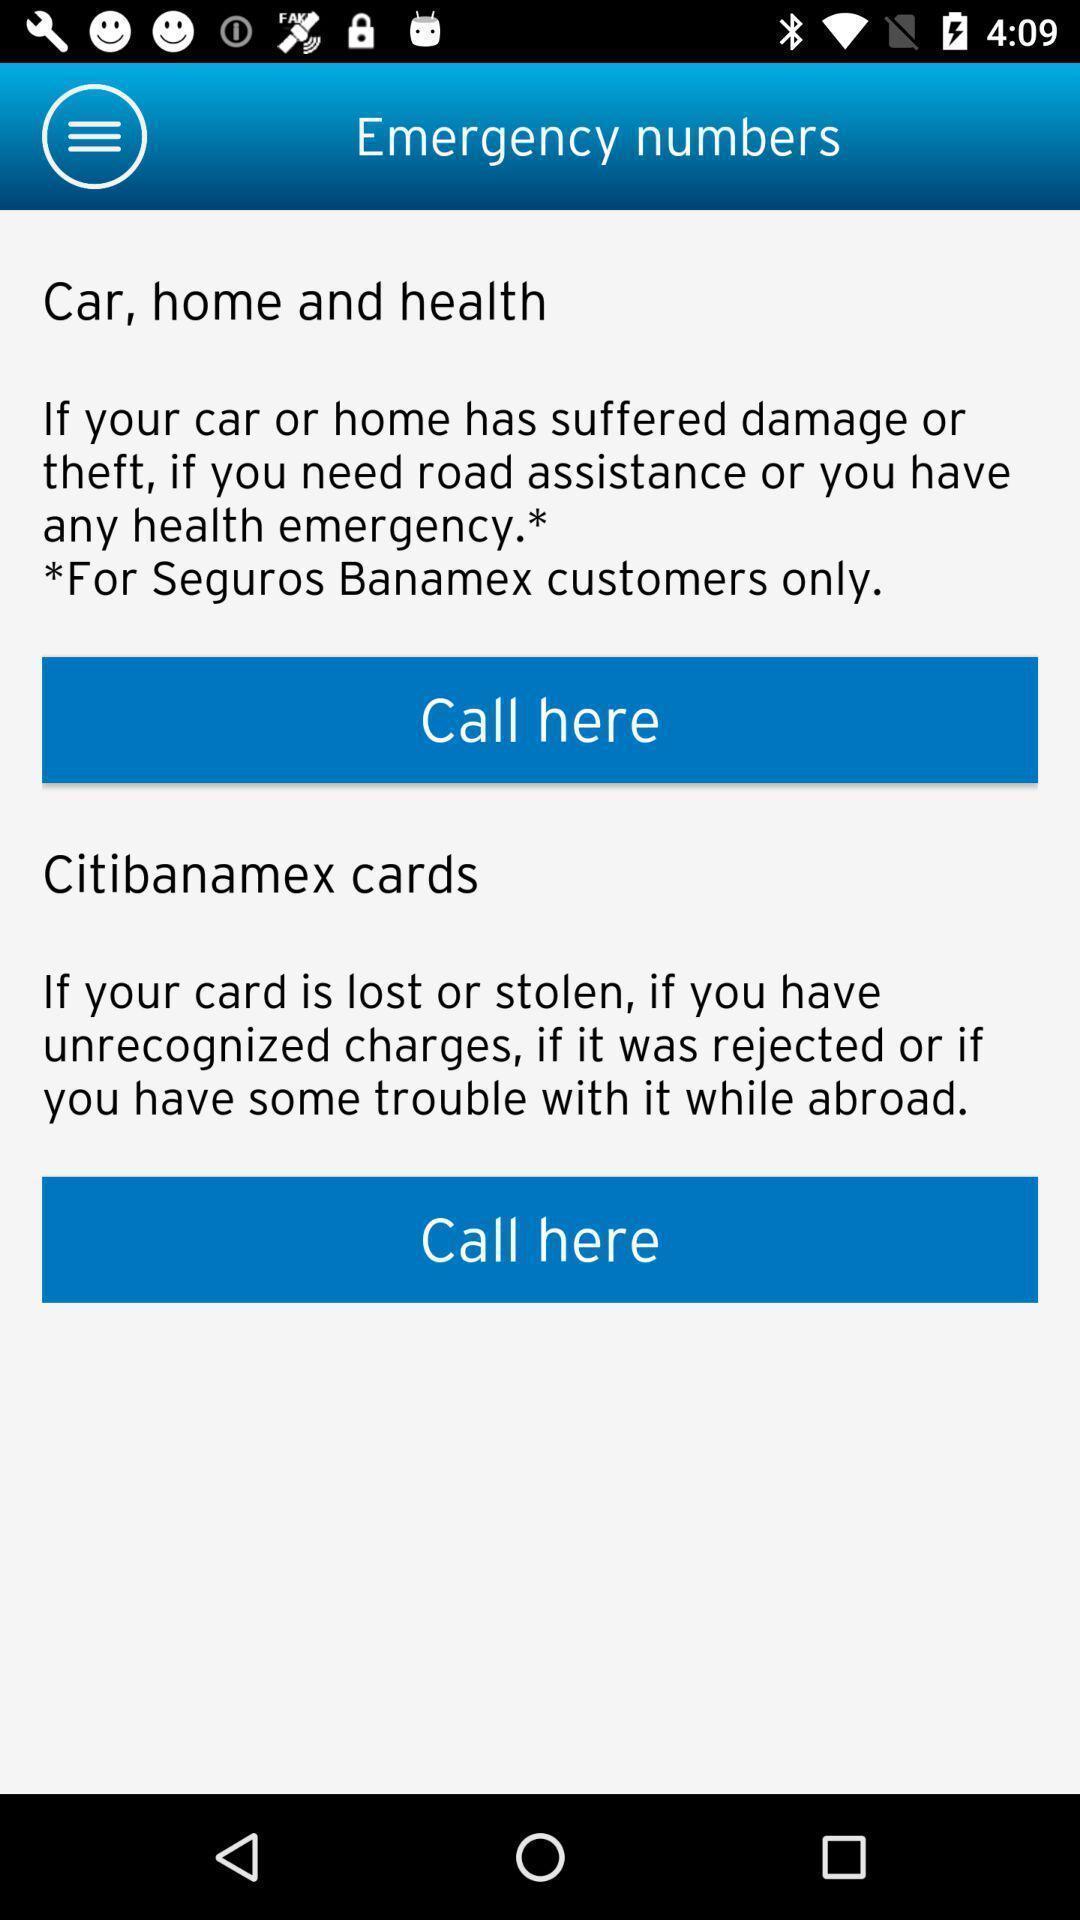Tell me what you see in this picture. Page displaying the emergency numbers. 